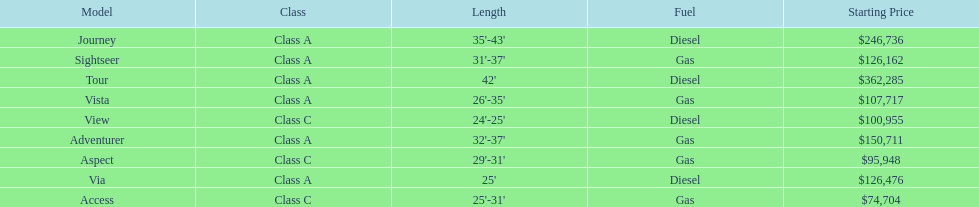What is the length of the aspect? 29'-31'. 